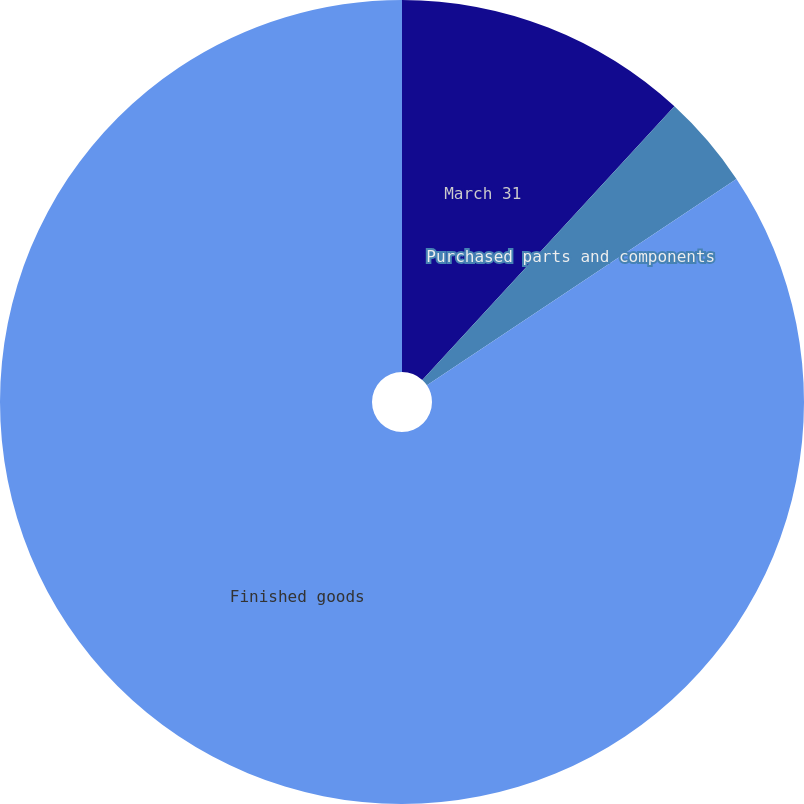Convert chart to OTSL. <chart><loc_0><loc_0><loc_500><loc_500><pie_chart><fcel>March 31<fcel>Purchased parts and components<fcel>Finished goods<nl><fcel>11.85%<fcel>3.79%<fcel>84.36%<nl></chart> 